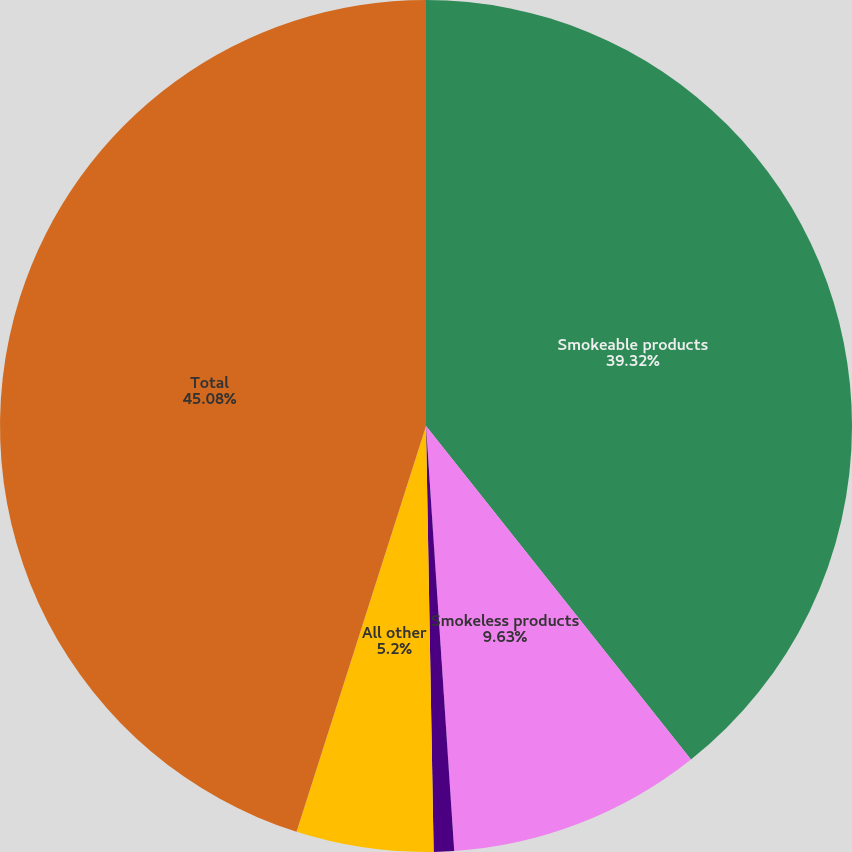Convert chart. <chart><loc_0><loc_0><loc_500><loc_500><pie_chart><fcel>Smokeable products<fcel>Smokeless products<fcel>Wine<fcel>All other<fcel>Total<nl><fcel>39.32%<fcel>9.63%<fcel>0.77%<fcel>5.2%<fcel>45.09%<nl></chart> 